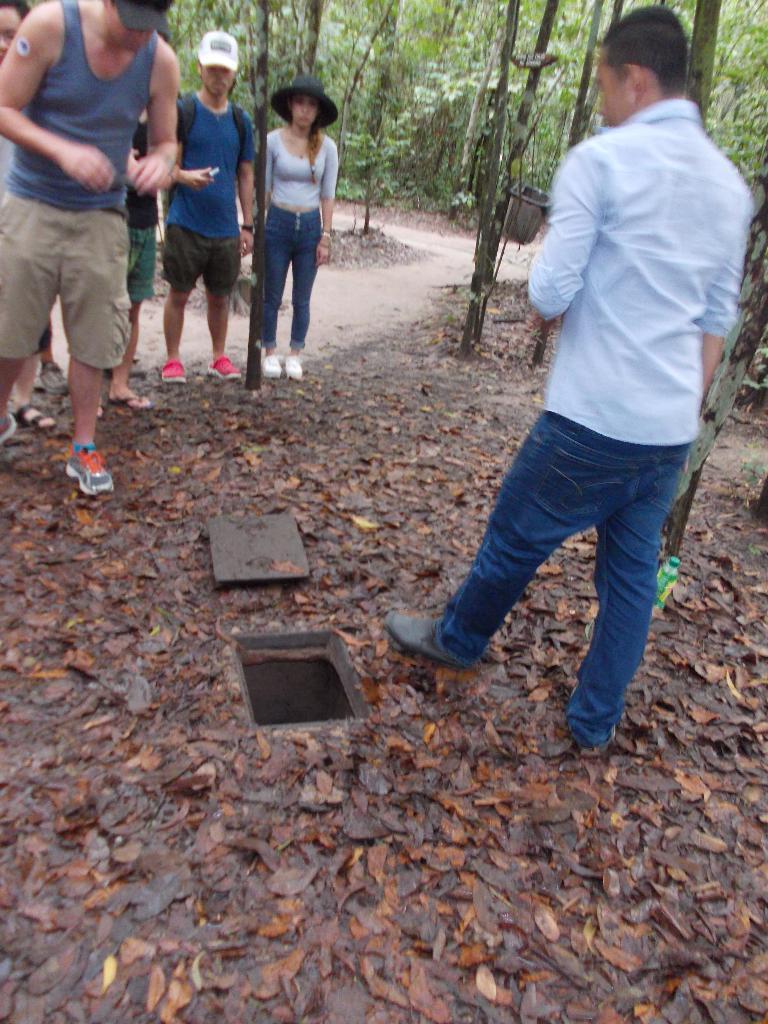Describe this image in one or two sentences. In this image there is a hole in the middle. There are so many dry leaves around the hole. Beside the hole there is a wooden plank. On the left side top there are few people who are standing on the ground and looking at the hole. On the right side there is a man standing on the ground beside the hole. In the background there are trees and there is a path in between them. 